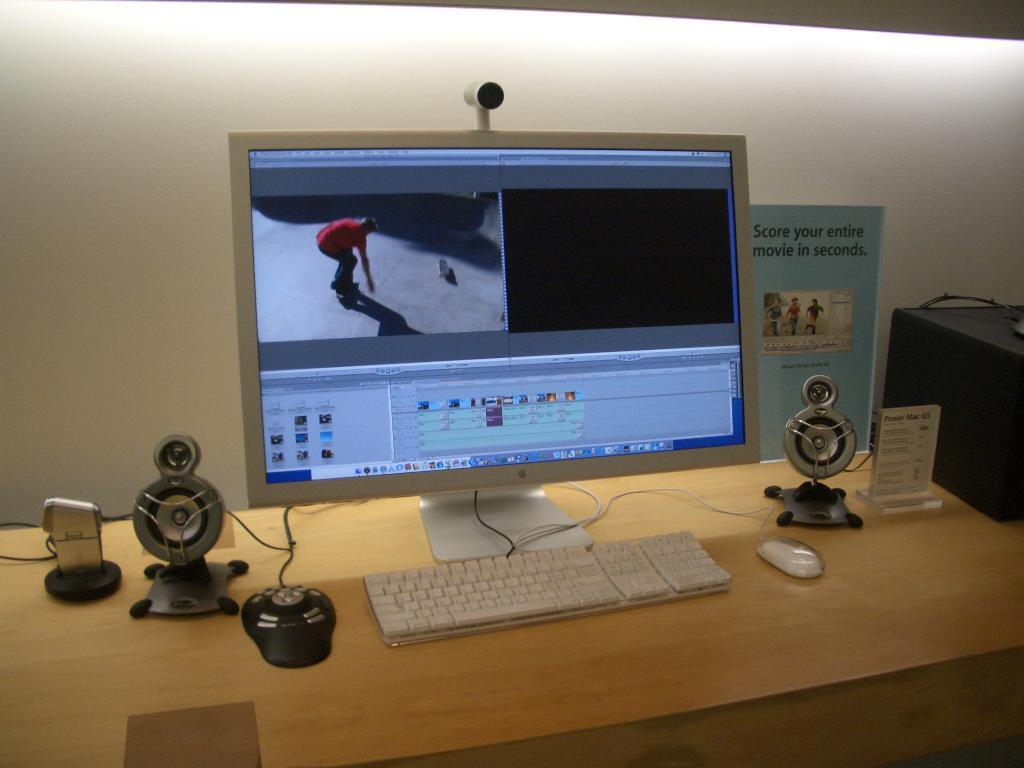<image>
Offer a succinct explanation of the picture presented. White apple monitor showing a man skateboarding next to a sign saying "Score your entire movie in seconds". 